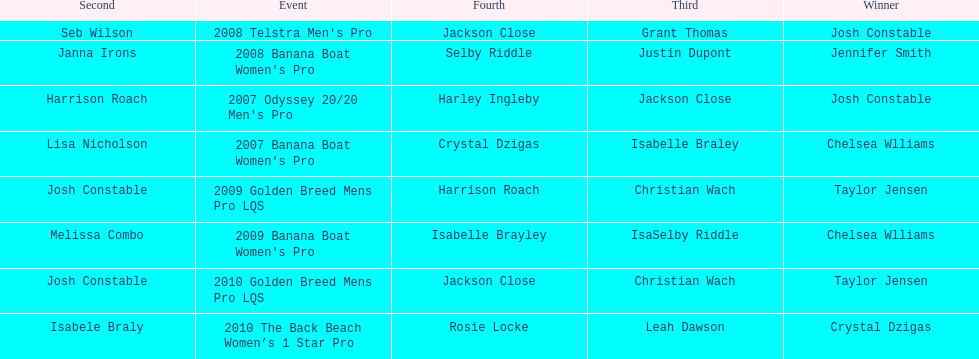Could you help me parse every detail presented in this table? {'header': ['Second', 'Event', 'Fourth', 'Third', 'Winner'], 'rows': [['Seb Wilson', "2008 Telstra Men's Pro", 'Jackson Close', 'Grant Thomas', 'Josh Constable'], ['Janna Irons', "2008 Banana Boat Women's Pro", 'Selby Riddle', 'Justin Dupont', 'Jennifer Smith'], ['Harrison Roach', "2007 Odyssey 20/20 Men's Pro", 'Harley Ingleby', 'Jackson Close', 'Josh Constable'], ['Lisa Nicholson', "2007 Banana Boat Women's Pro", 'Crystal Dzigas', 'Isabelle Braley', 'Chelsea Wlliams'], ['Josh Constable', '2009 Golden Breed Mens Pro LQS', 'Harrison Roach', 'Christian Wach', 'Taylor Jensen'], ['Melissa Combo', "2009 Banana Boat Women's Pro", 'Isabelle Brayley', 'IsaSelby Riddle', 'Chelsea Wlliams'], ['Josh Constable', '2010 Golden Breed Mens Pro LQS', 'Jackson Close', 'Christian Wach', 'Taylor Jensen'], ['Isabele Braly', '2010 The Back Beach Women’s 1 Star Pro', 'Rosie Locke', 'Leah Dawson', 'Crystal Dzigas']]} In what two races did chelsea williams earn the same rank? 2007 Banana Boat Women's Pro, 2009 Banana Boat Women's Pro. 